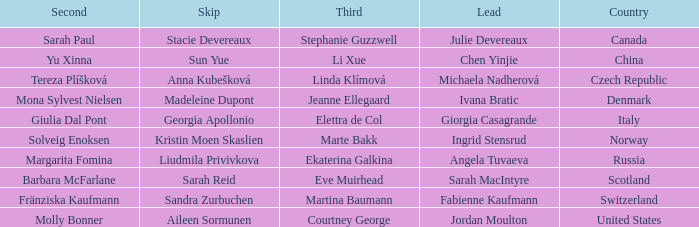What skip has martina baumann as the third? Sandra Zurbuchen. 